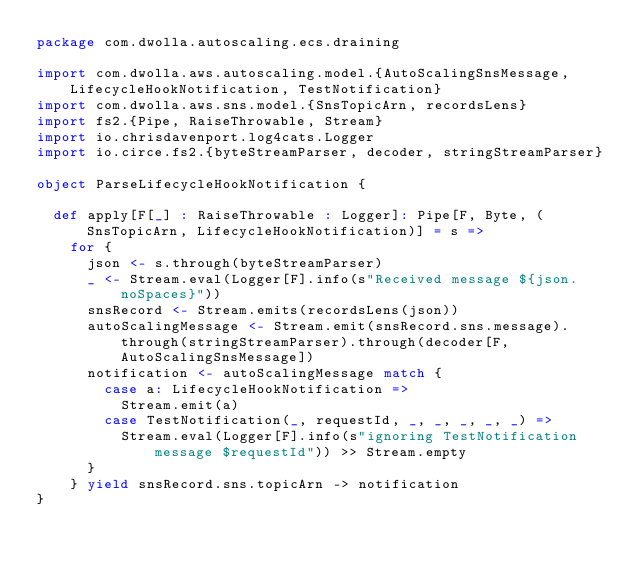<code> <loc_0><loc_0><loc_500><loc_500><_Scala_>package com.dwolla.autoscaling.ecs.draining

import com.dwolla.aws.autoscaling.model.{AutoScalingSnsMessage, LifecycleHookNotification, TestNotification}
import com.dwolla.aws.sns.model.{SnsTopicArn, recordsLens}
import fs2.{Pipe, RaiseThrowable, Stream}
import io.chrisdavenport.log4cats.Logger
import io.circe.fs2.{byteStreamParser, decoder, stringStreamParser}

object ParseLifecycleHookNotification {

  def apply[F[_] : RaiseThrowable : Logger]: Pipe[F, Byte, (SnsTopicArn, LifecycleHookNotification)] = s =>
    for {
      json <- s.through(byteStreamParser)
      _ <- Stream.eval(Logger[F].info(s"Received message ${json.noSpaces}"))
      snsRecord <- Stream.emits(recordsLens(json))
      autoScalingMessage <- Stream.emit(snsRecord.sns.message).through(stringStreamParser).through(decoder[F, AutoScalingSnsMessage])
      notification <- autoScalingMessage match {
        case a: LifecycleHookNotification =>
          Stream.emit(a)
        case TestNotification(_, requestId, _, _, _, _, _) =>
          Stream.eval(Logger[F].info(s"ignoring TestNotification message $requestId")) >> Stream.empty
      }
    } yield snsRecord.sns.topicArn -> notification
}
</code> 